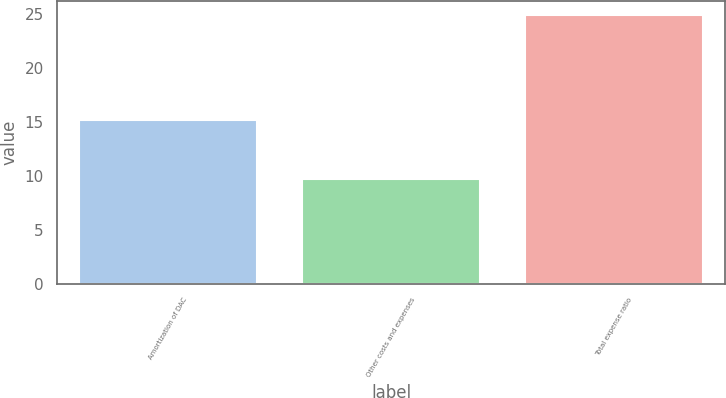Convert chart. <chart><loc_0><loc_0><loc_500><loc_500><bar_chart><fcel>Amortization of DAC<fcel>Other costs and expenses<fcel>Total expense ratio<nl><fcel>15.1<fcel>9.7<fcel>24.9<nl></chart> 